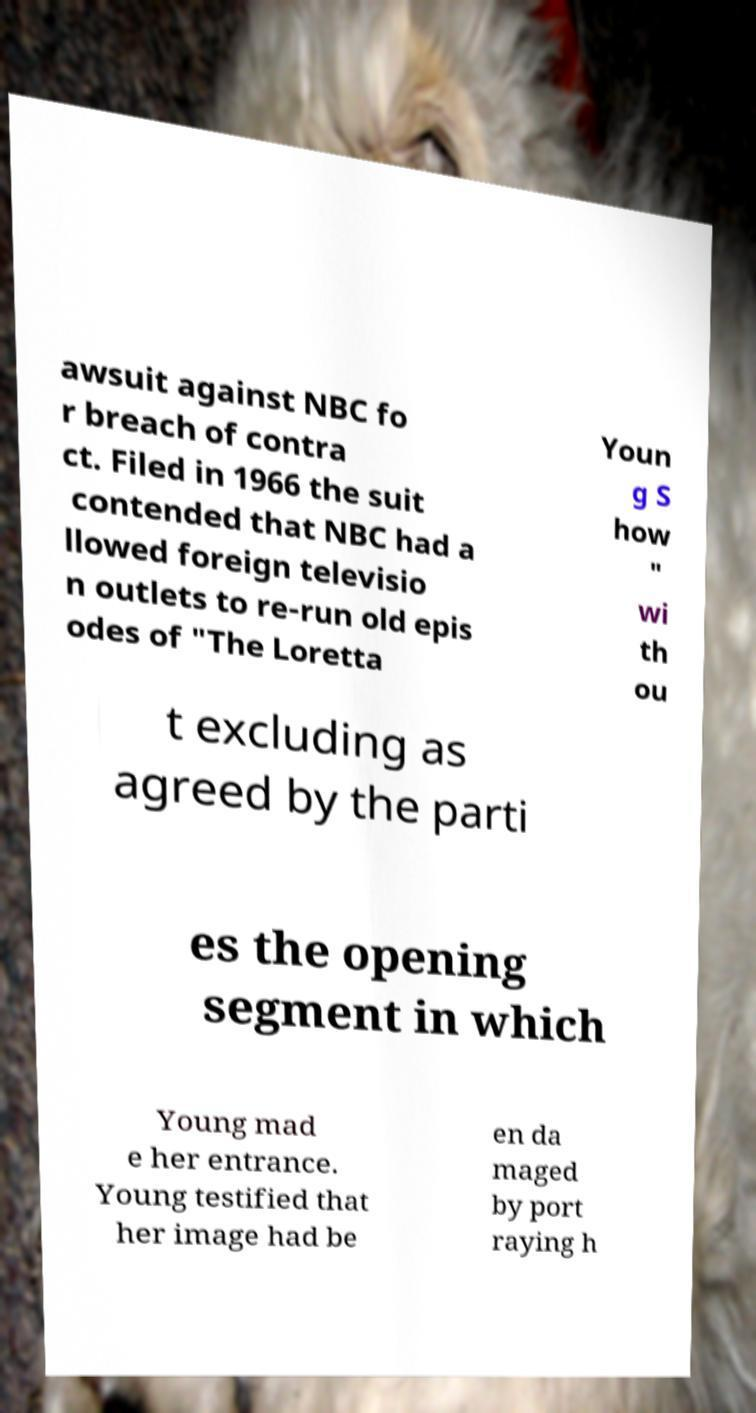There's text embedded in this image that I need extracted. Can you transcribe it verbatim? awsuit against NBC fo r breach of contra ct. Filed in 1966 the suit contended that NBC had a llowed foreign televisio n outlets to re-run old epis odes of "The Loretta Youn g S how " wi th ou t excluding as agreed by the parti es the opening segment in which Young mad e her entrance. Young testified that her image had be en da maged by port raying h 